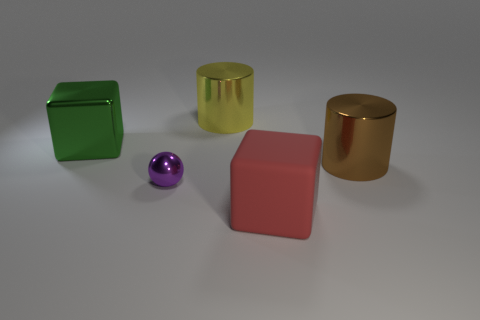Add 2 large cyan shiny cylinders. How many objects exist? 7 Subtract all blocks. How many objects are left? 3 Add 4 large brown metallic things. How many large brown metallic things are left? 5 Add 3 small green spheres. How many small green spheres exist? 3 Subtract 0 blue cubes. How many objects are left? 5 Subtract all small green cylinders. Subtract all green objects. How many objects are left? 4 